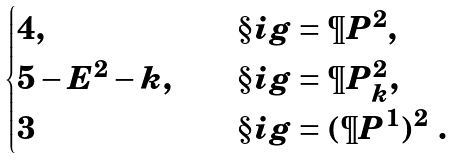<formula> <loc_0><loc_0><loc_500><loc_500>\begin{cases} 4 , \quad & \S i g = \P P ^ { 2 } , \\ 5 - E ^ { 2 } - k , \quad & \S i g = \P P ^ { 2 } _ { k } , \\ 3 \quad & \S i g = ( \P P ^ { 1 } ) ^ { 2 } \ . \end{cases}</formula> 